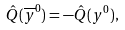Convert formula to latex. <formula><loc_0><loc_0><loc_500><loc_500>\hat { Q } ( \overline { y } ^ { 0 } ) = - \hat { Q } ( { y } ^ { 0 } ) ,</formula> 